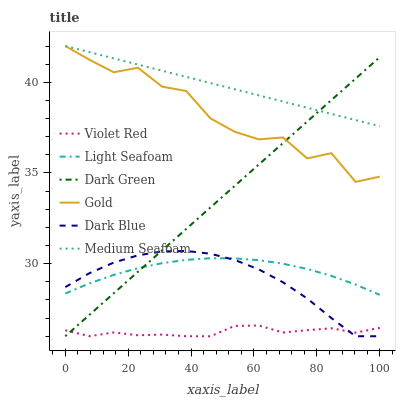Does Violet Red have the minimum area under the curve?
Answer yes or no. Yes. Does Medium Seafoam have the maximum area under the curve?
Answer yes or no. Yes. Does Gold have the minimum area under the curve?
Answer yes or no. No. Does Gold have the maximum area under the curve?
Answer yes or no. No. Is Medium Seafoam the smoothest?
Answer yes or no. Yes. Is Gold the roughest?
Answer yes or no. Yes. Is Dark Blue the smoothest?
Answer yes or no. No. Is Dark Blue the roughest?
Answer yes or no. No. Does Violet Red have the lowest value?
Answer yes or no. Yes. Does Gold have the lowest value?
Answer yes or no. No. Does Medium Seafoam have the highest value?
Answer yes or no. Yes. Does Dark Blue have the highest value?
Answer yes or no. No. Is Dark Blue less than Medium Seafoam?
Answer yes or no. Yes. Is Medium Seafoam greater than Violet Red?
Answer yes or no. Yes. Does Dark Green intersect Light Seafoam?
Answer yes or no. Yes. Is Dark Green less than Light Seafoam?
Answer yes or no. No. Is Dark Green greater than Light Seafoam?
Answer yes or no. No. Does Dark Blue intersect Medium Seafoam?
Answer yes or no. No. 